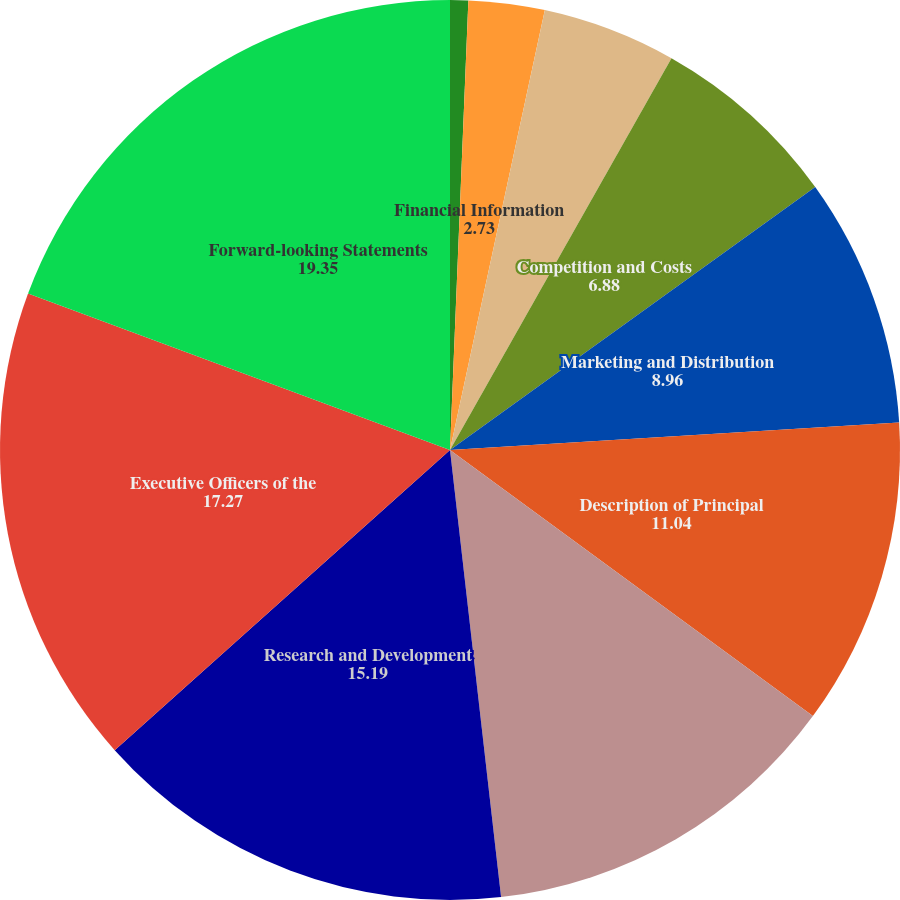Convert chart. <chart><loc_0><loc_0><loc_500><loc_500><pie_chart><fcel>General<fcel>Financial Information<fcel>Financial Information About<fcel>Competition and Costs<fcel>Marketing and Distribution<fcel>Description of Principal<fcel>Sales Volumes by Product<fcel>Research and Development<fcel>Executive Officers of the<fcel>Forward-looking Statements<nl><fcel>0.65%<fcel>2.73%<fcel>4.81%<fcel>6.88%<fcel>8.96%<fcel>11.04%<fcel>13.12%<fcel>15.19%<fcel>17.27%<fcel>19.35%<nl></chart> 